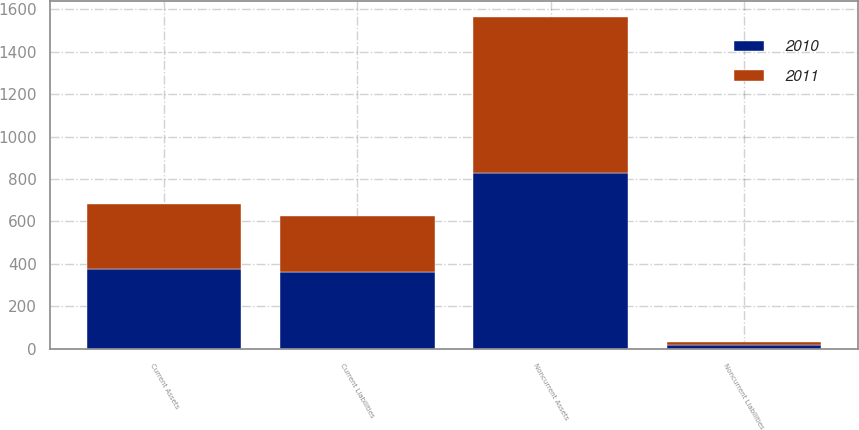<chart> <loc_0><loc_0><loc_500><loc_500><stacked_bar_chart><ecel><fcel>Current Assets<fcel>Noncurrent Assets<fcel>Current Liabilities<fcel>Noncurrent Liabilities<nl><fcel>2010<fcel>374<fcel>827<fcel>360<fcel>16<nl><fcel>2011<fcel>307<fcel>735<fcel>265<fcel>16<nl></chart> 